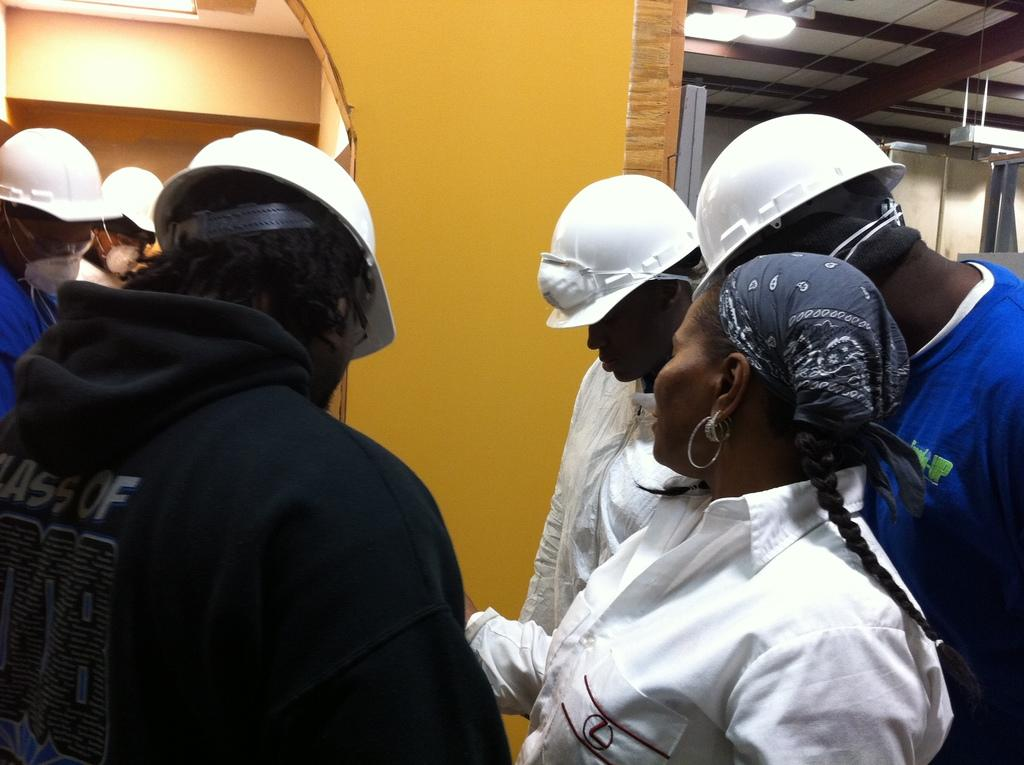How many people are in the image? There are people in the image, but the exact number is not specified. What are some of the people wearing? Some of the people are wearing helmets. What can be seen in the background of the image? There is a wall in the background of the image. What is the source of illumination in the image? There is a light visible in the image. What type of steel is used to construct the ear in the image? There is no ear or steel present in the image. 